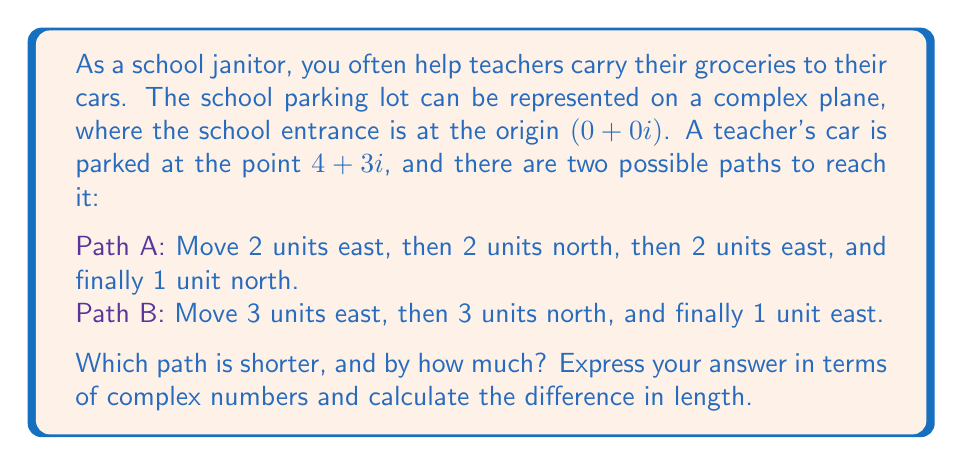Help me with this question. Let's approach this step-by-step using complex number representation:

1) First, let's represent each path as a sum of complex numbers:

   Path A: $$(2+0i) + (0+2i) + (2+0i) + (0+1i) = 4+3i$$
   Path B: $$(3+0i) + (0+3i) + (1+0i) = 4+3i$$

2) Both paths end at the same point (4+3i), which confirms they both reach the car.

3) To find the length of each path, we need to sum the magnitudes of each step:

   Path A length: $$|2+0i| + |0+2i| + |2+0i| + |0+1i| = 2 + 2 + 2 + 1 = 7$$
   Path B length: $$|3+0i| + |0+3i| + |1+0i| = 3 + 3 + 1 = 7$$

4) The difference in length is:
   $$7 - 7 = 0$$

5) We can also represent this difference as a complex number:
   $$0 + 0i$$
Answer: Both paths have the same length of 7 units. The difference in length is $0 + 0i$. 